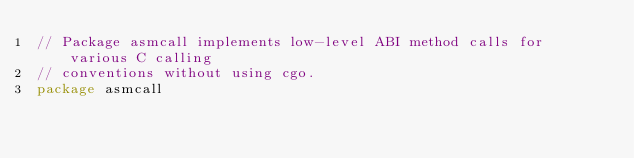Convert code to text. <code><loc_0><loc_0><loc_500><loc_500><_Go_>// Package asmcall implements low-level ABI method calls for various C calling
// conventions without using cgo.
package asmcall
</code> 